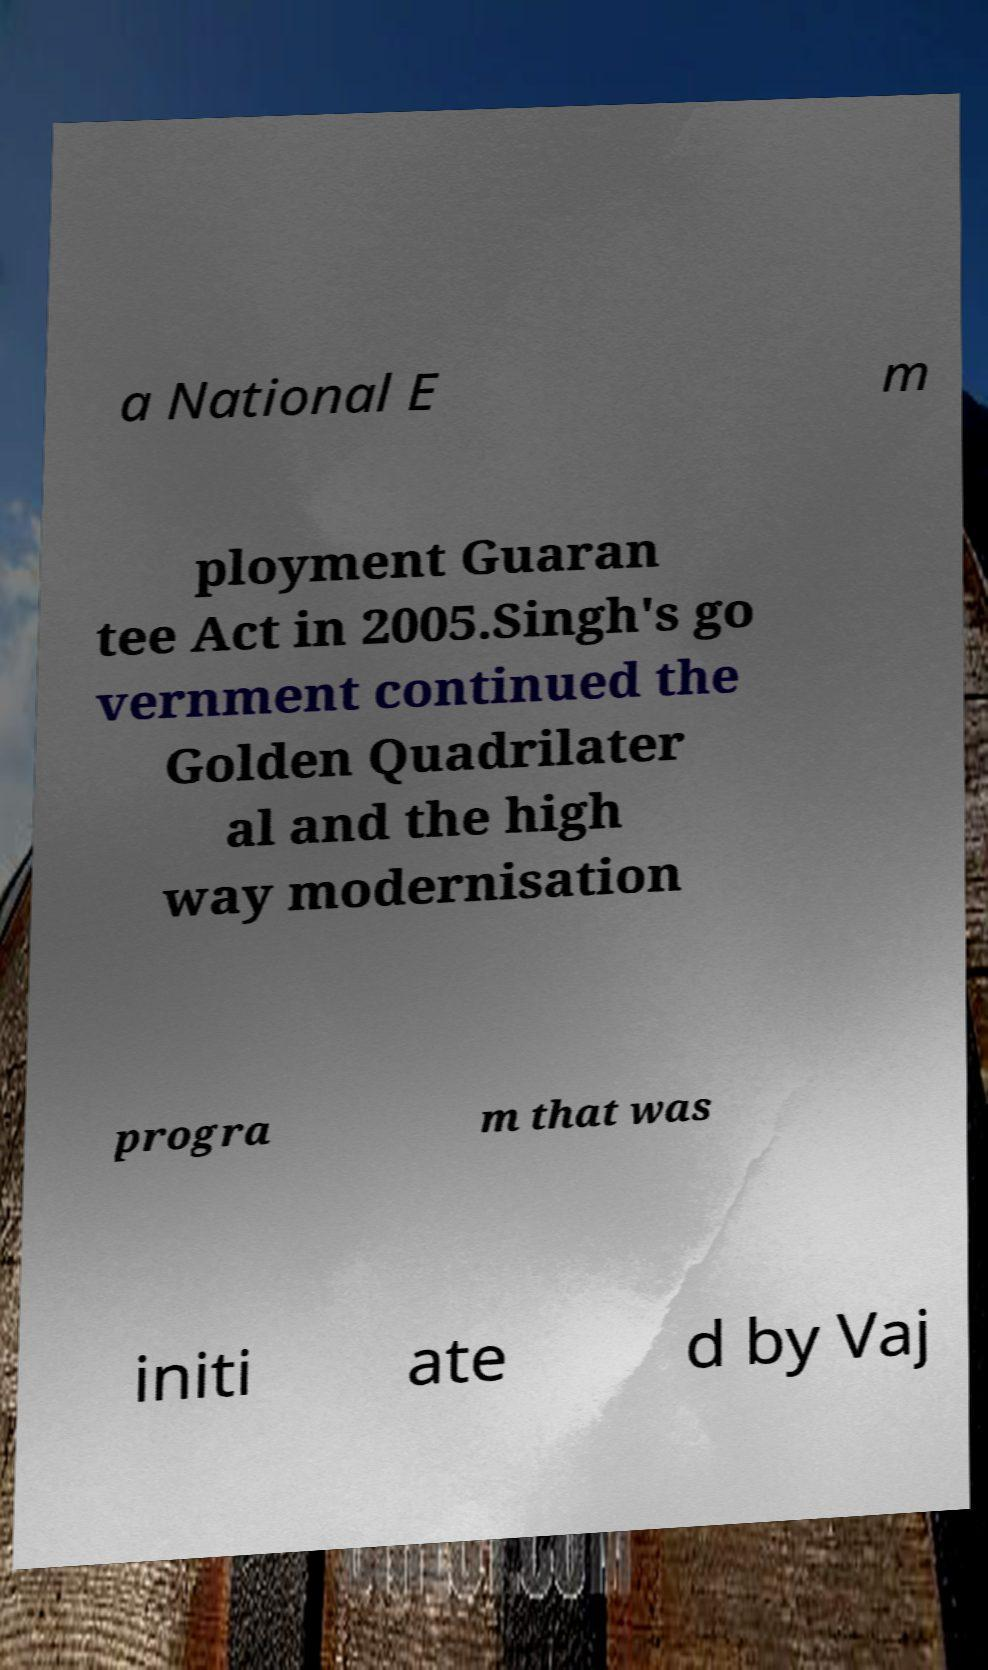For documentation purposes, I need the text within this image transcribed. Could you provide that? a National E m ployment Guaran tee Act in 2005.Singh's go vernment continued the Golden Quadrilater al and the high way modernisation progra m that was initi ate d by Vaj 